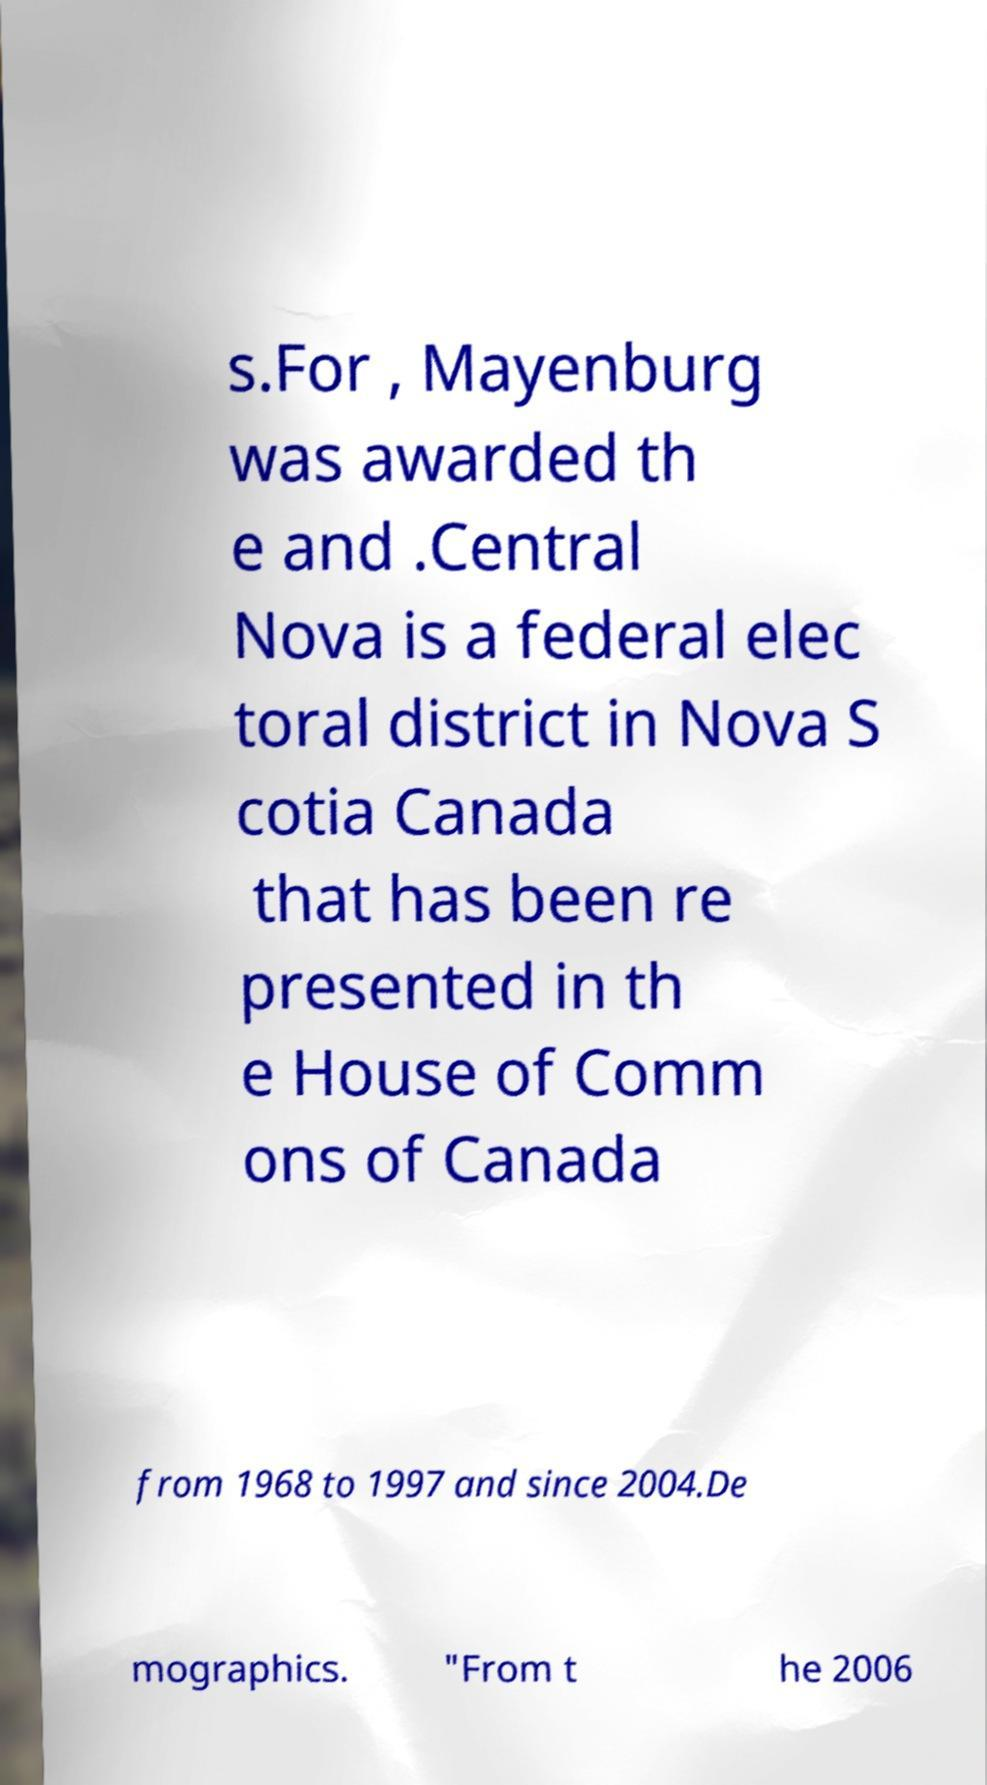Could you extract and type out the text from this image? s.For , Mayenburg was awarded th e and .Central Nova is a federal elec toral district in Nova S cotia Canada that has been re presented in th e House of Comm ons of Canada from 1968 to 1997 and since 2004.De mographics. "From t he 2006 